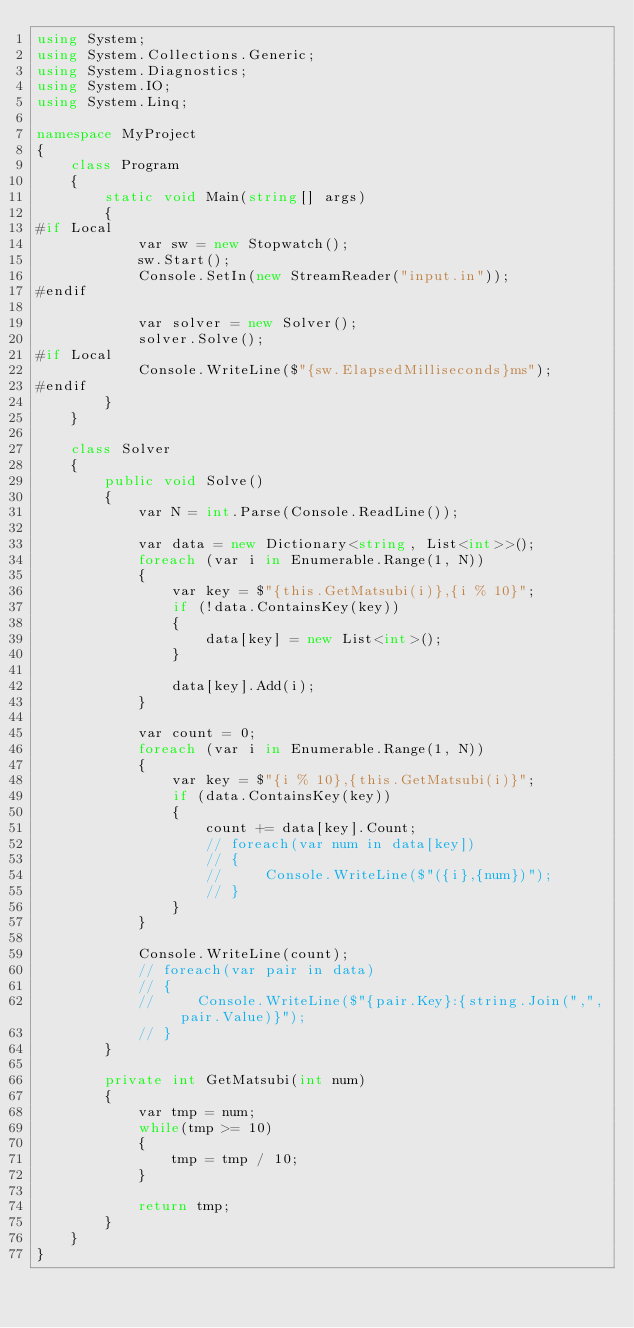Convert code to text. <code><loc_0><loc_0><loc_500><loc_500><_C#_>using System;
using System.Collections.Generic;
using System.Diagnostics;
using System.IO;
using System.Linq;

namespace MyProject
{
    class Program
    {
        static void Main(string[] args)
        {
#if Local
            var sw = new Stopwatch();
            sw.Start();
            Console.SetIn(new StreamReader("input.in"));
#endif

            var solver = new Solver();
            solver.Solve();
#if Local
            Console.WriteLine($"{sw.ElapsedMilliseconds}ms");
#endif
        }
    }

    class Solver
    {
        public void Solve()
        {
            var N = int.Parse(Console.ReadLine());

            var data = new Dictionary<string, List<int>>();
            foreach (var i in Enumerable.Range(1, N))
            {
                var key = $"{this.GetMatsubi(i)},{i % 10}";
                if (!data.ContainsKey(key))
                {
                    data[key] = new List<int>();
                }

                data[key].Add(i);
            }

            var count = 0;
            foreach (var i in Enumerable.Range(1, N))
            {
                var key = $"{i % 10},{this.GetMatsubi(i)}";
                if (data.ContainsKey(key))
                {
                    count += data[key].Count;
                    // foreach(var num in data[key])
                    // {
                    //     Console.WriteLine($"({i},{num})");
                    // }
                }
            }

            Console.WriteLine(count);
            // foreach(var pair in data)
            // {
            //     Console.WriteLine($"{pair.Key}:{string.Join(",", pair.Value)}");
            // }
        }

        private int GetMatsubi(int num)
        {
            var tmp = num;
            while(tmp >= 10)
            {
                tmp = tmp / 10;
            }

            return tmp;
        }
    }
}
</code> 